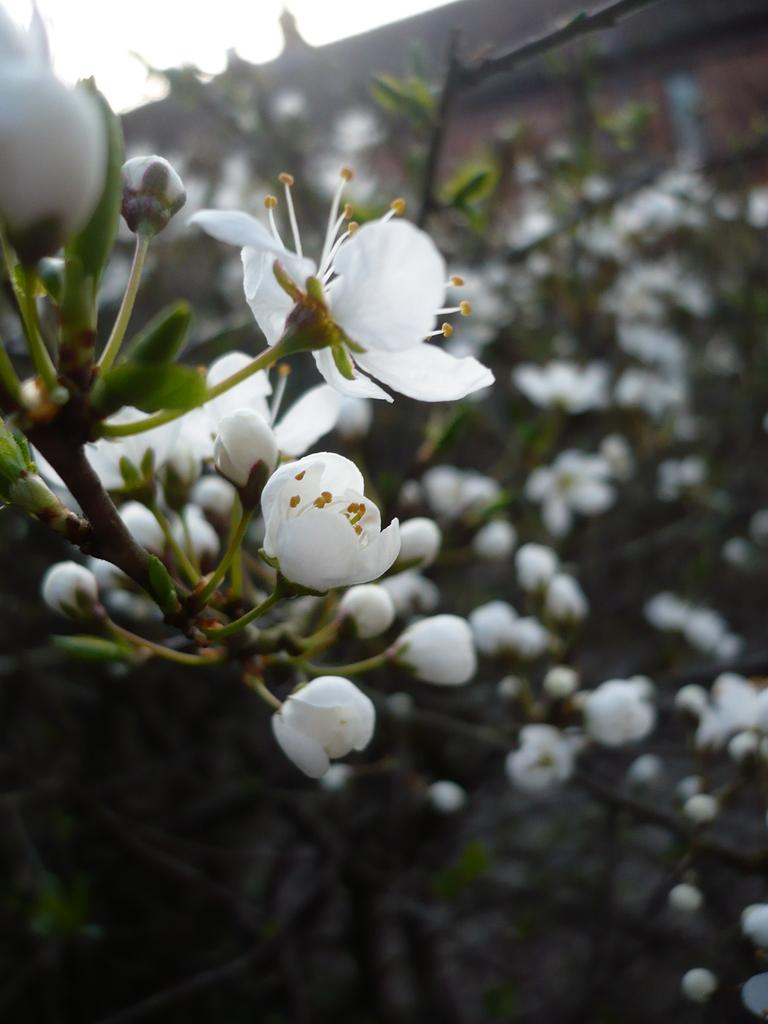What type of flowers can be seen in the image? There are white-colored flowers in the image. Can you describe the overall quality of the image? The image is slightly blurry in the background. Where is the throne located in the image? There is no throne present in the image; it only features white-colored flowers. 